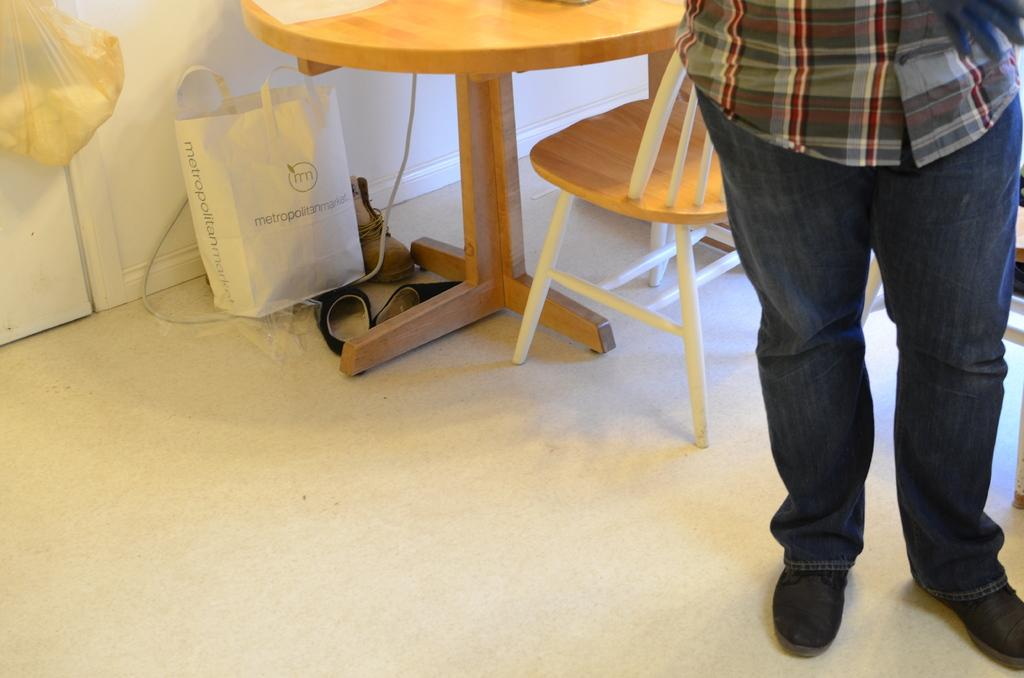What is the main subject in the image? There is a man standing in the image. What object can be seen next to the man? There is a table in the image. What piece of furniture is missing from the scene? There is an empty chair in the image. What is located under the table? There is a white bag under the table. What type of footwear is visible in the image? There are shoes visible in the image. Where is the polythene bag placed in the image? There is a polythene bag hanging on the wall. What type of operation is being performed on the man in the image? There is no operation being performed on the man in the image; he is simply standing. What unit is responsible for the man's presence in the image? There is no specific unit mentioned or implied in the image. 